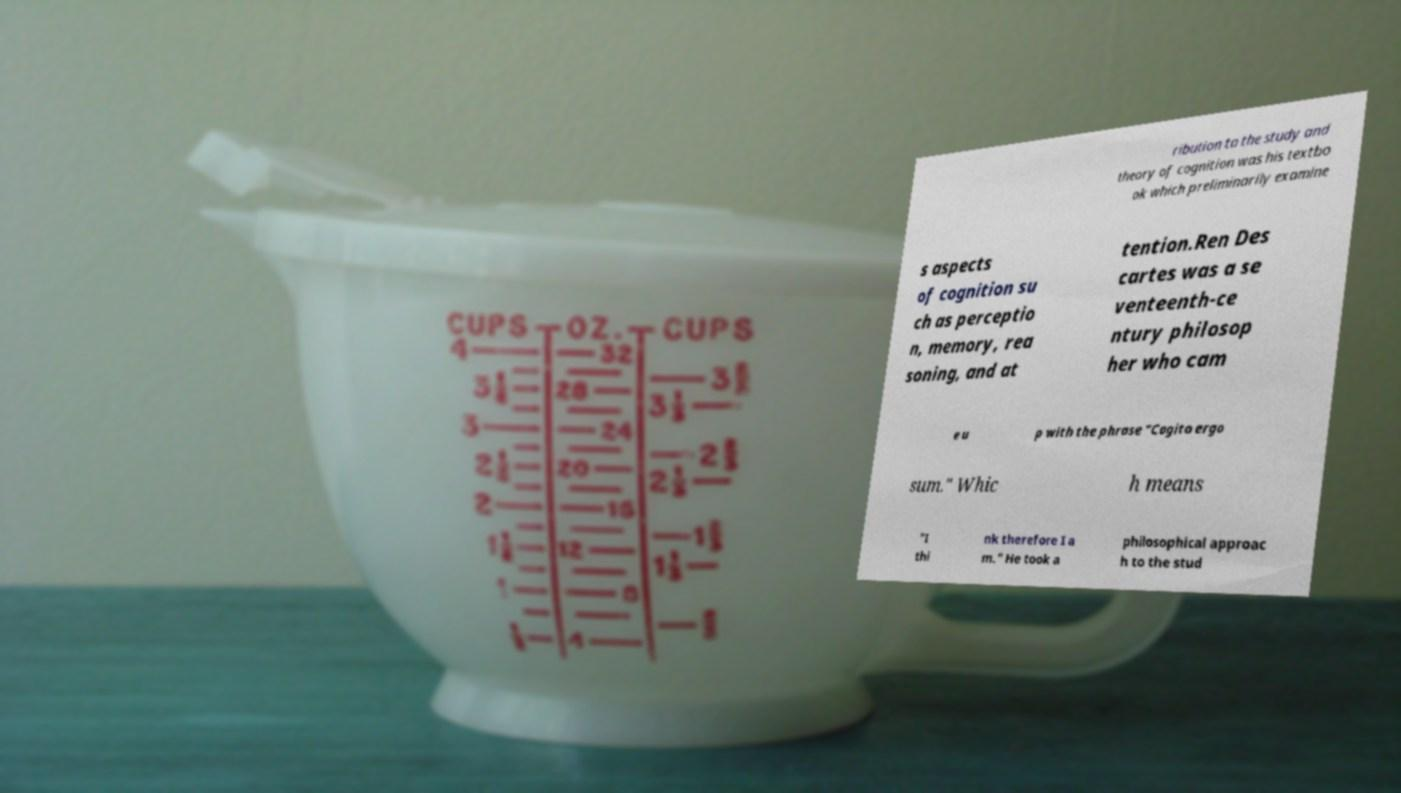What messages or text are displayed in this image? I need them in a readable, typed format. ribution to the study and theory of cognition was his textbo ok which preliminarily examine s aspects of cognition su ch as perceptio n, memory, rea soning, and at tention.Ren Des cartes was a se venteenth-ce ntury philosop her who cam e u p with the phrase "Cogito ergo sum." Whic h means "I thi nk therefore I a m." He took a philosophical approac h to the stud 